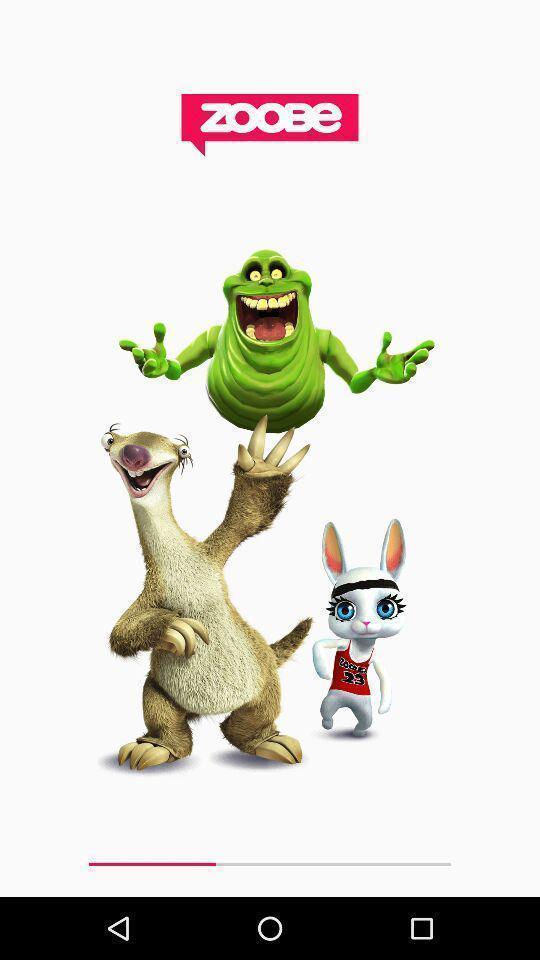Give me a narrative description of this picture. Screen shows different images. 